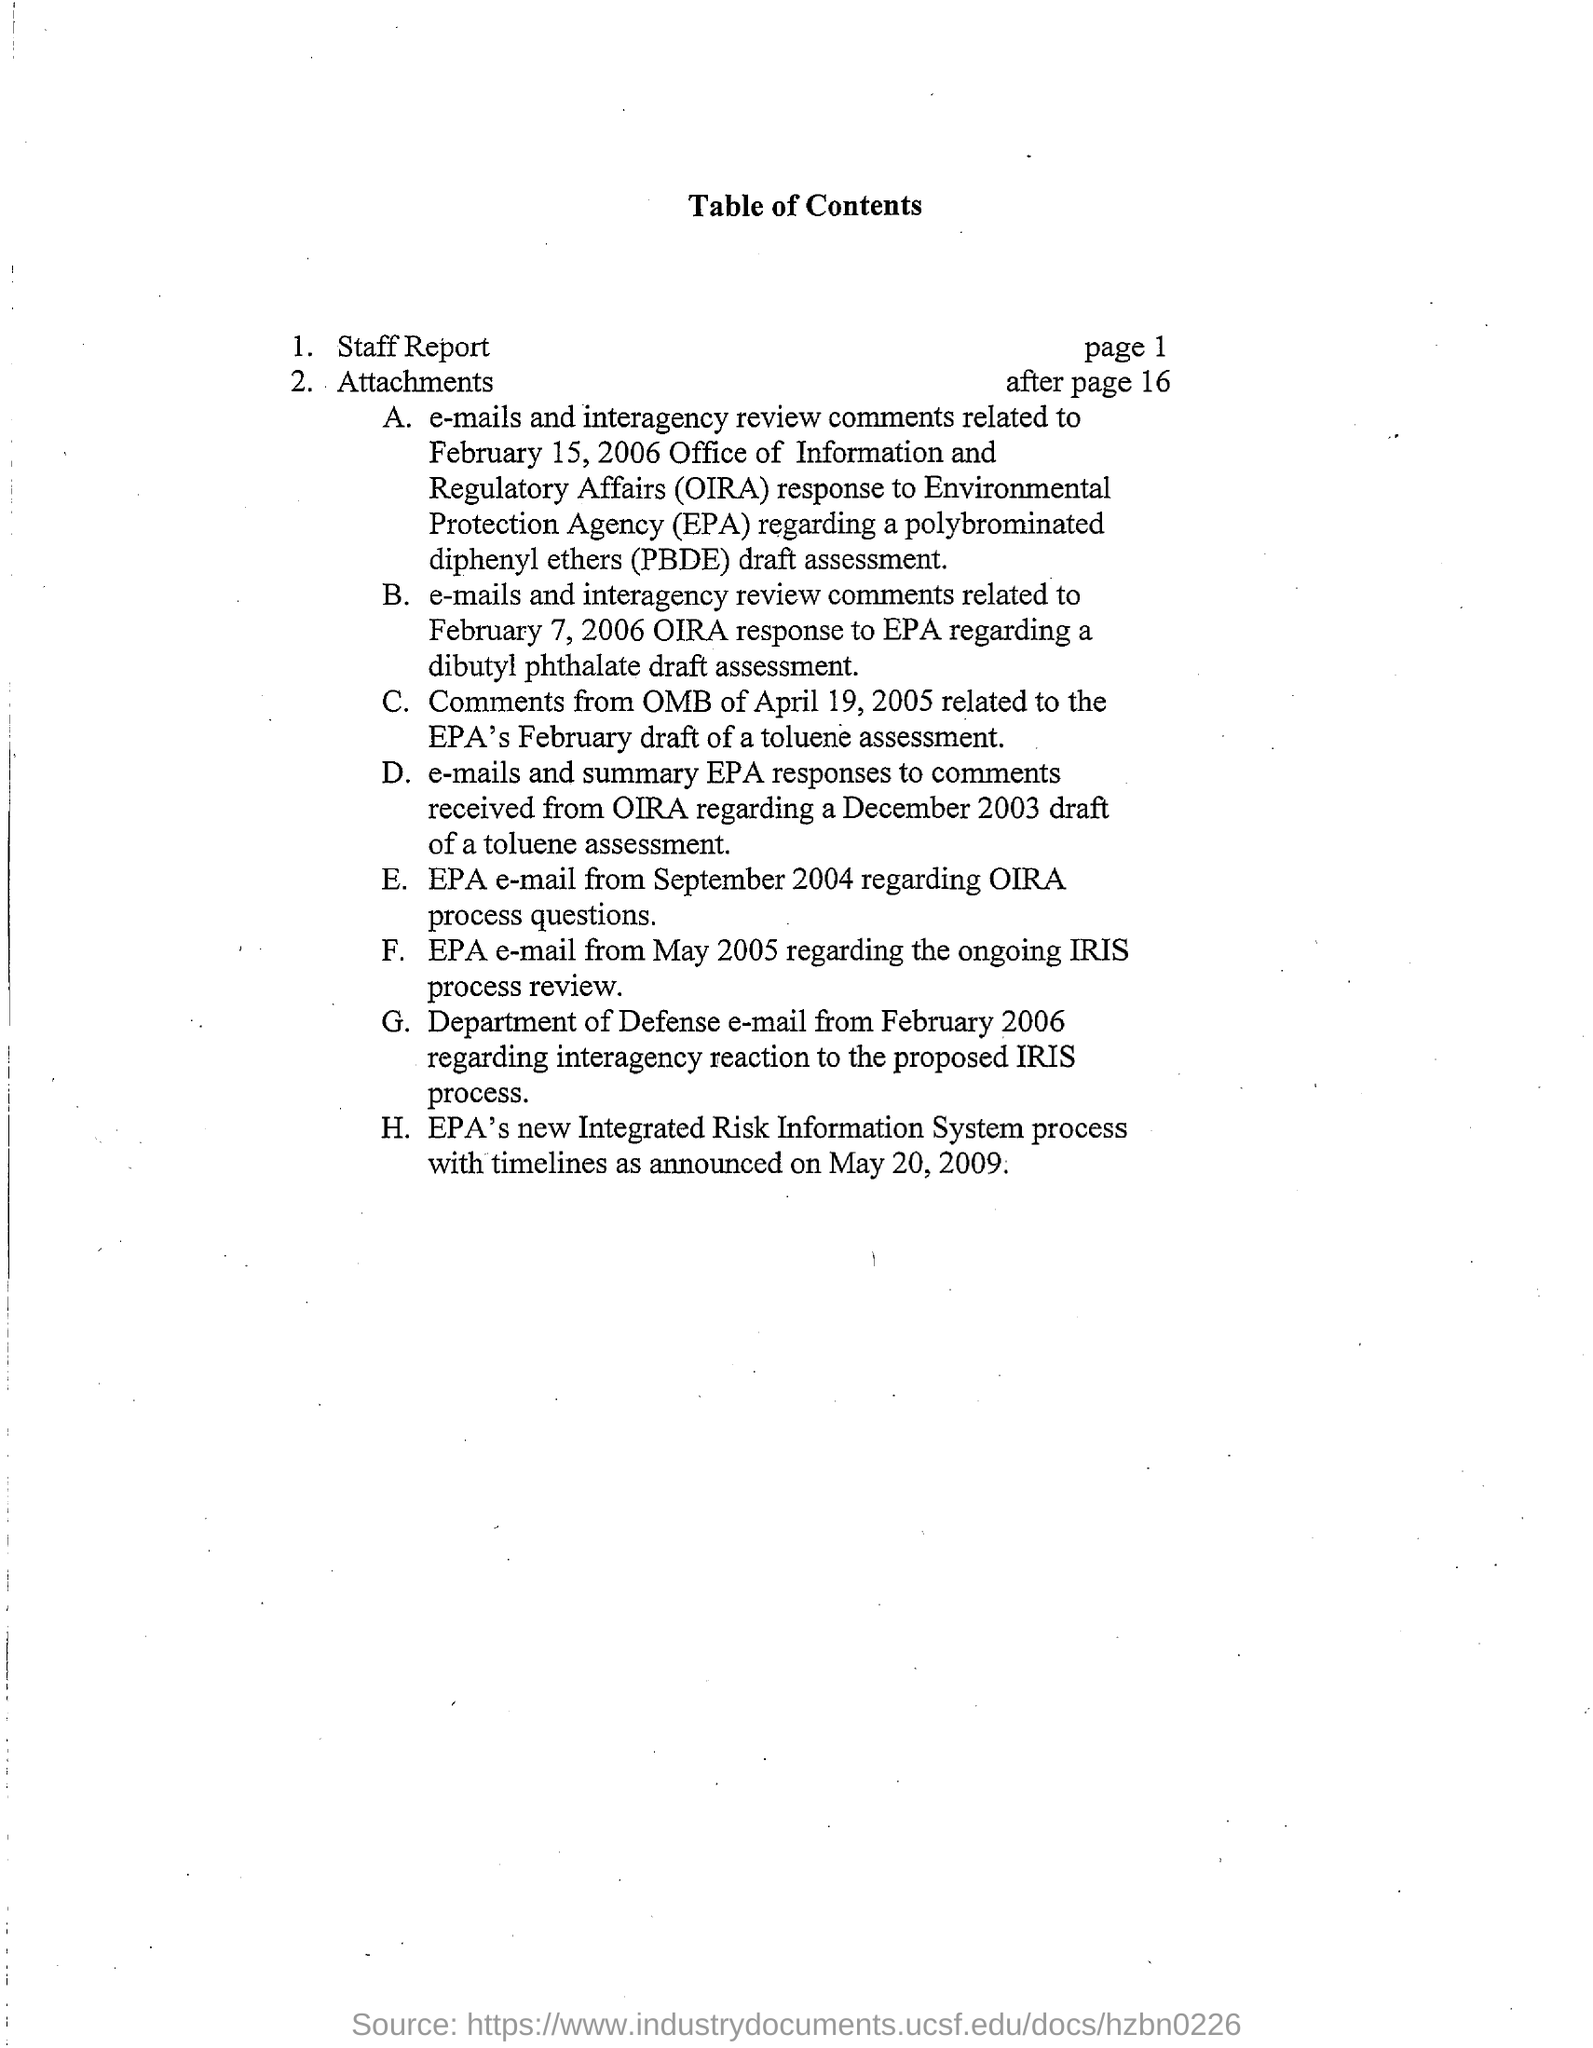What does OIRA stand for?
Your response must be concise. OFFICE OF INFORMATION AND REGULATORY AFFAIRS. What does EPA stand for?
Provide a short and direct response. Environmental Protection Agency. What does PBDE stand for?
Make the answer very short. Polybrominated Diphenyl Ethers. 